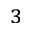<formula> <loc_0><loc_0><loc_500><loc_500>^ { 3 }</formula> 